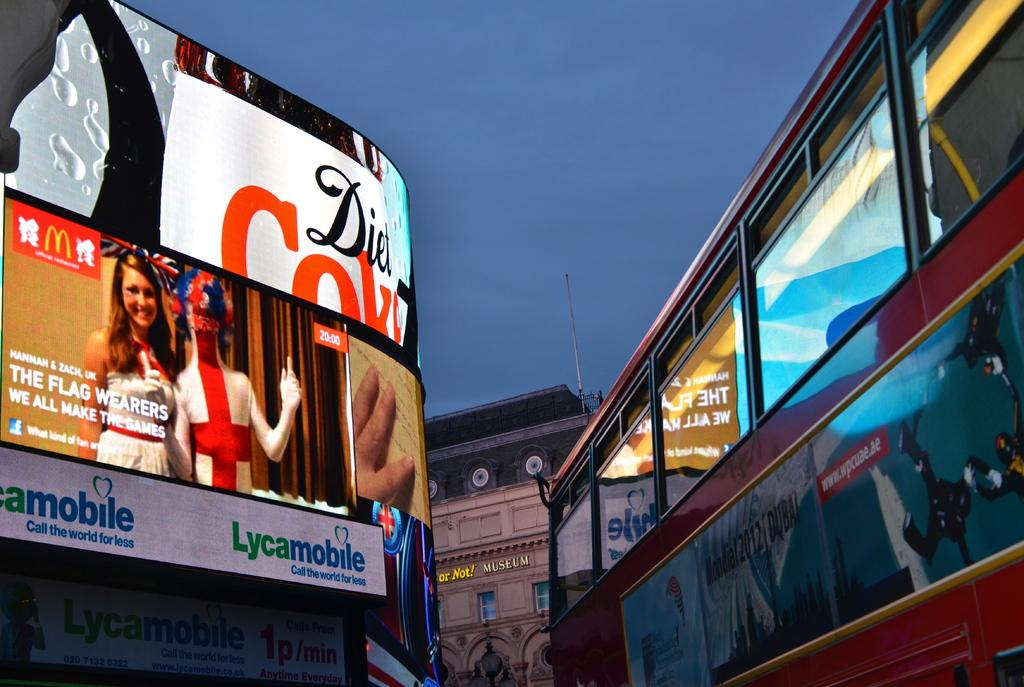<image>
Provide a brief description of the given image. The word Lycamobile is below a sign showing two women. 